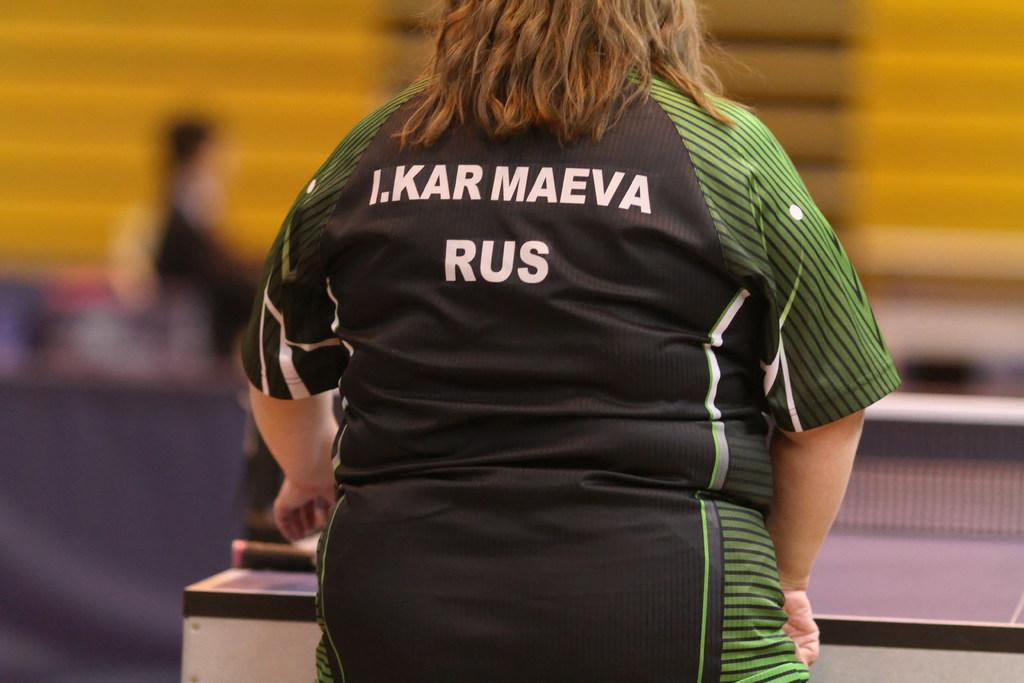<image>
Create a compact narrative representing the image presented. A table tennis player wearing a shirt with the name I. Kar Maeva on the back. 